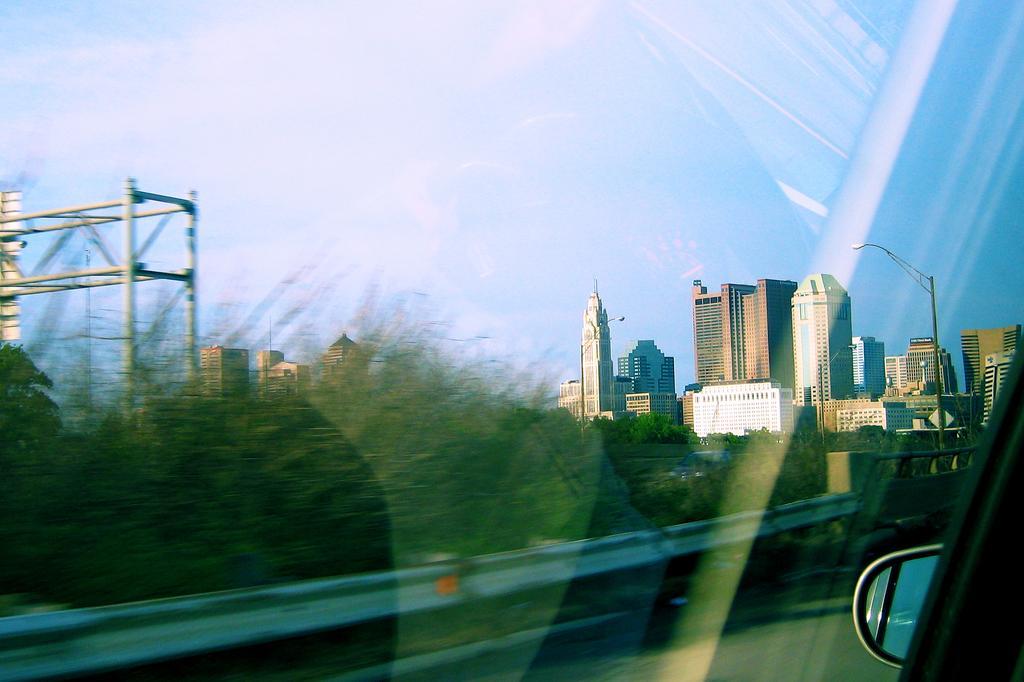Can you describe this image briefly? In this image I can see buildings, street lights, trees and the sky in the background. 